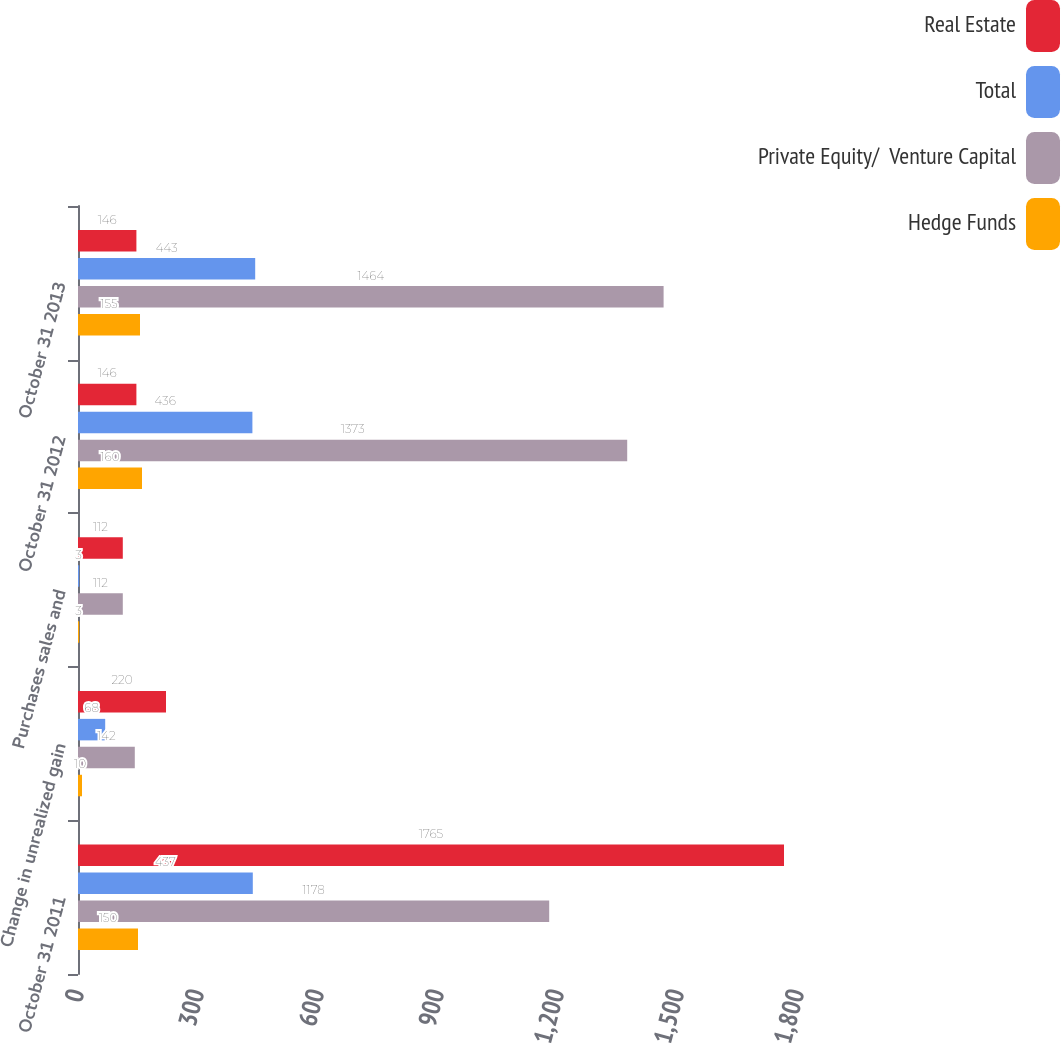Convert chart. <chart><loc_0><loc_0><loc_500><loc_500><stacked_bar_chart><ecel><fcel>October 31 2011<fcel>Change in unrealized gain<fcel>Purchases sales and<fcel>October 31 2012<fcel>October 31 2013<nl><fcel>Real Estate<fcel>1765<fcel>220<fcel>112<fcel>146<fcel>146<nl><fcel>Total<fcel>437<fcel>68<fcel>3<fcel>436<fcel>443<nl><fcel>Private Equity/  Venture Capital<fcel>1178<fcel>142<fcel>112<fcel>1373<fcel>1464<nl><fcel>Hedge Funds<fcel>150<fcel>10<fcel>3<fcel>160<fcel>155<nl></chart> 